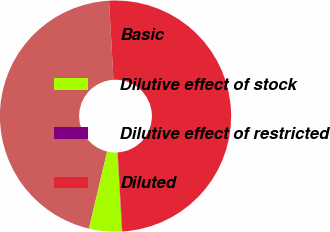<chart> <loc_0><loc_0><loc_500><loc_500><pie_chart><fcel>Basic<fcel>Dilutive effect of stock<fcel>Dilutive effect of restricted<fcel>Diluted<nl><fcel>45.41%<fcel>4.59%<fcel>0.04%<fcel>49.96%<nl></chart> 